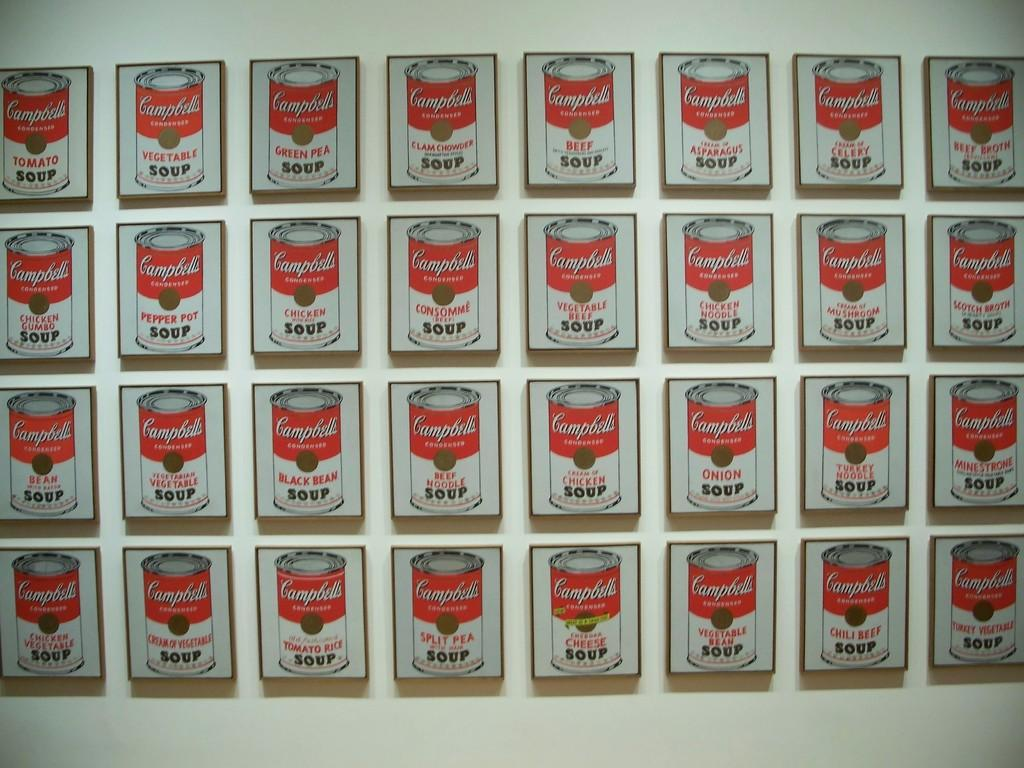Provide a one-sentence caption for the provided image. Small wall hangings displaying different flavors of Campbell's Soup. 